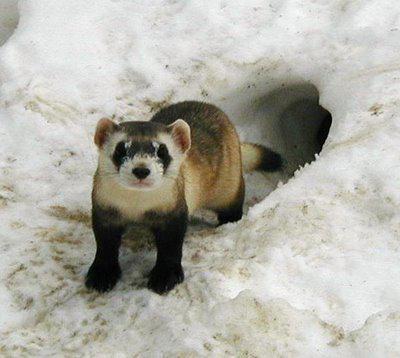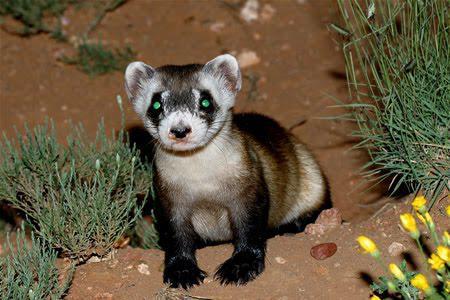The first image is the image on the left, the second image is the image on the right. For the images shown, is this caption "at least one ferret is standing on the dirt with tufts of grass around it in the image pair" true? Answer yes or no. Yes. The first image is the image on the left, the second image is the image on the right. Examine the images to the left and right. Is the description "There are two weasels that have black and white coloring." accurate? Answer yes or no. Yes. 